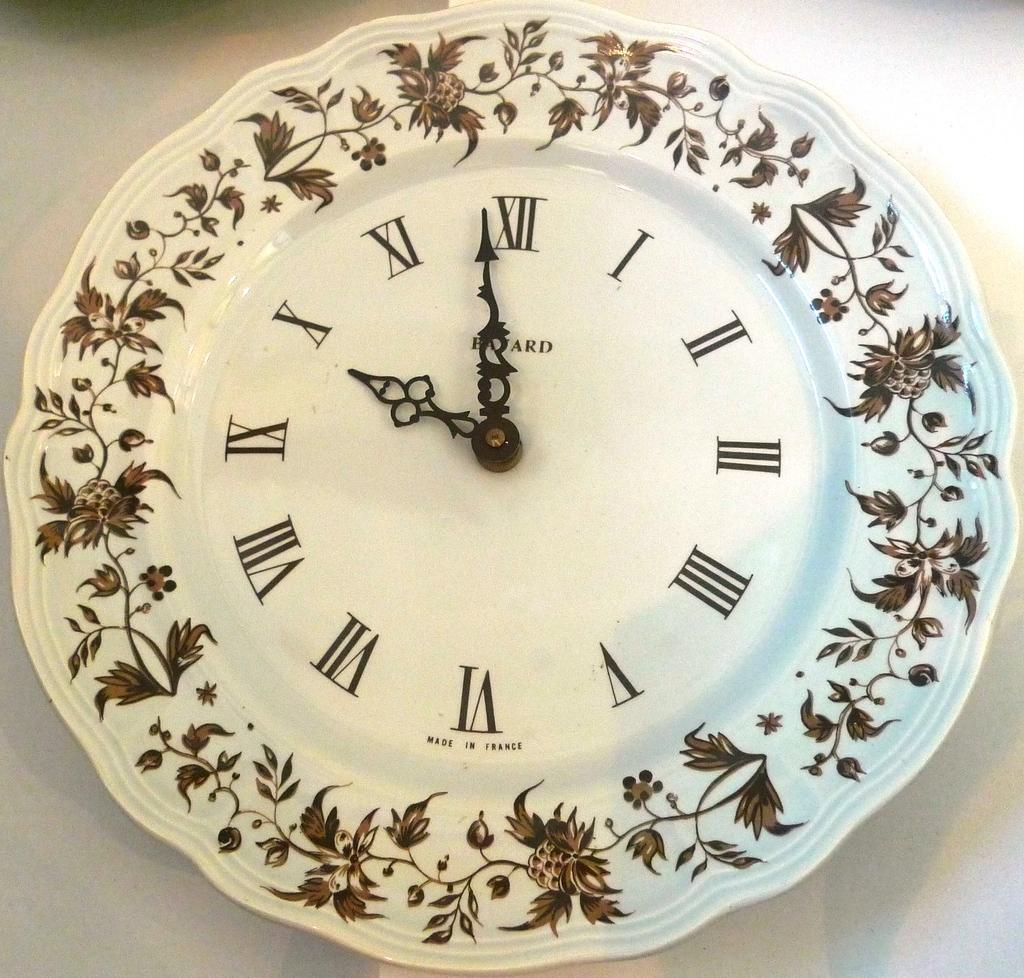<image>
Render a clear and concise summary of the photo. A clock that looks like a dinner plate shows the time as a minute before ten. 